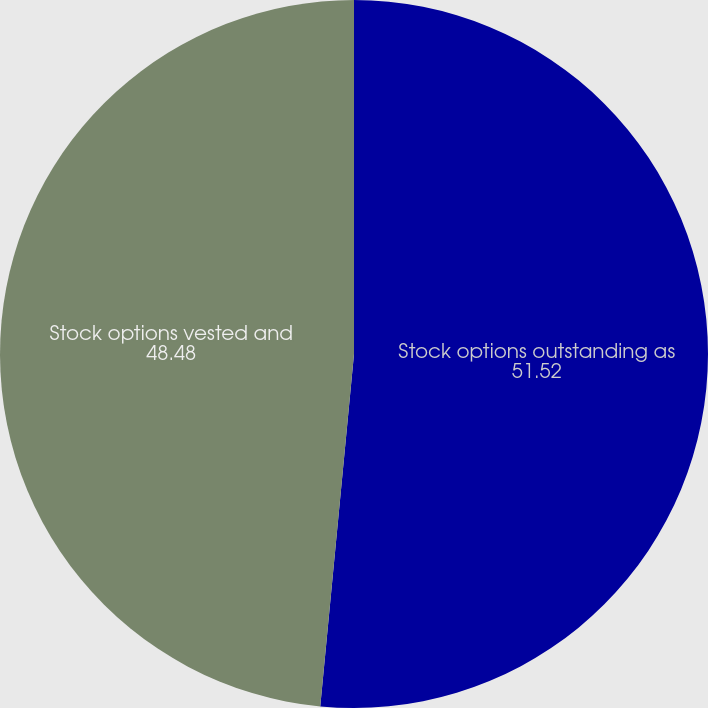Convert chart. <chart><loc_0><loc_0><loc_500><loc_500><pie_chart><fcel>Stock options outstanding as<fcel>Stock options vested and<nl><fcel>51.52%<fcel>48.48%<nl></chart> 